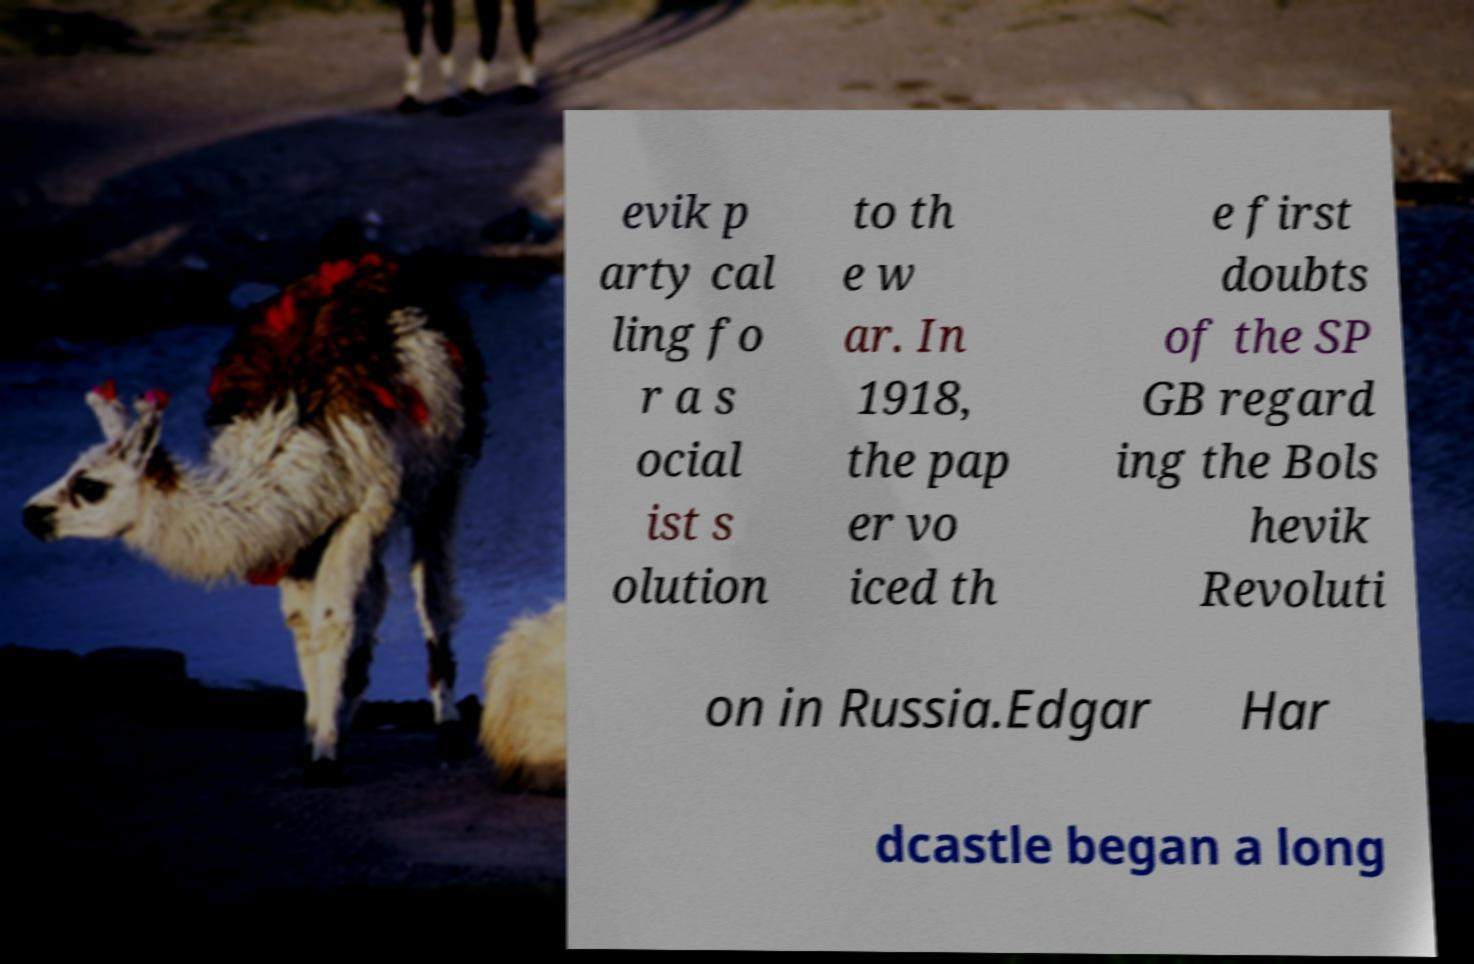What messages or text are displayed in this image? I need them in a readable, typed format. evik p arty cal ling fo r a s ocial ist s olution to th e w ar. In 1918, the pap er vo iced th e first doubts of the SP GB regard ing the Bols hevik Revoluti on in Russia.Edgar Har dcastle began a long 